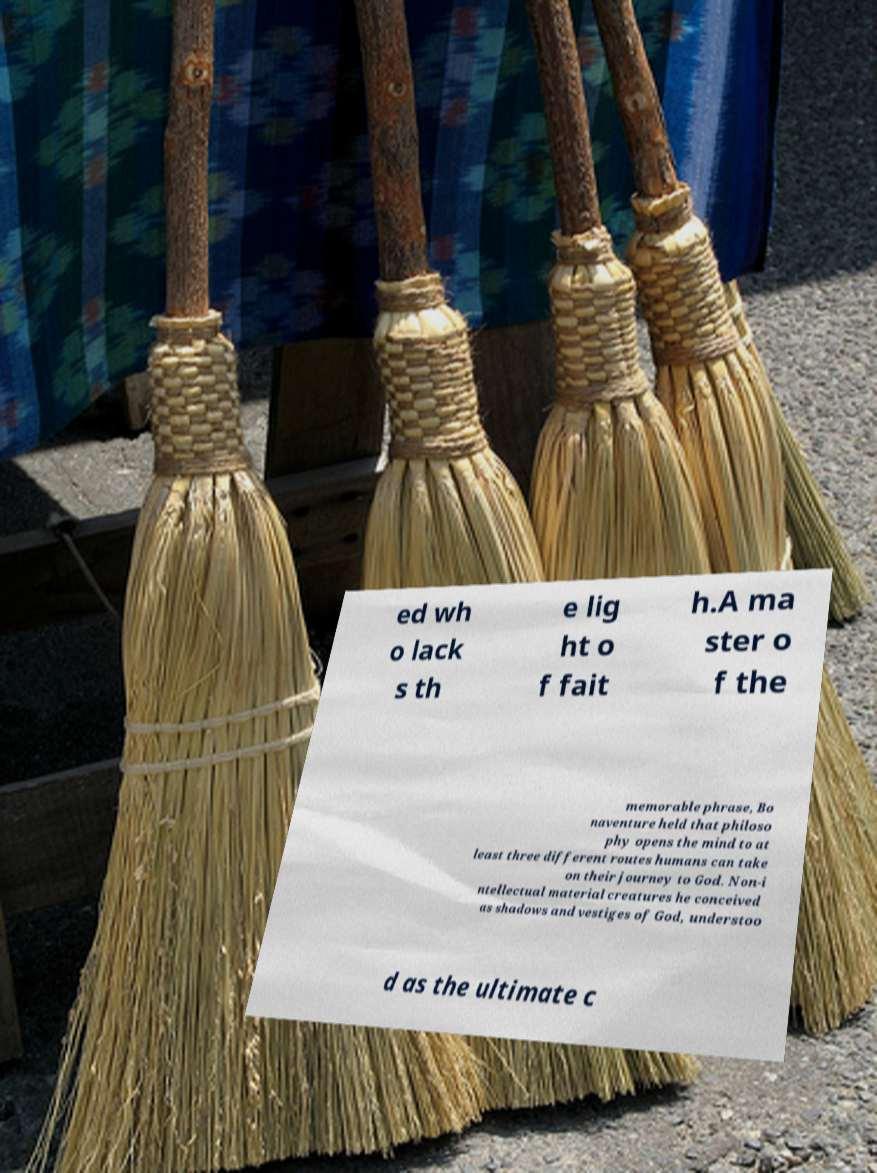Please read and relay the text visible in this image. What does it say? ed wh o lack s th e lig ht o f fait h.A ma ster o f the memorable phrase, Bo naventure held that philoso phy opens the mind to at least three different routes humans can take on their journey to God. Non-i ntellectual material creatures he conceived as shadows and vestiges of God, understoo d as the ultimate c 